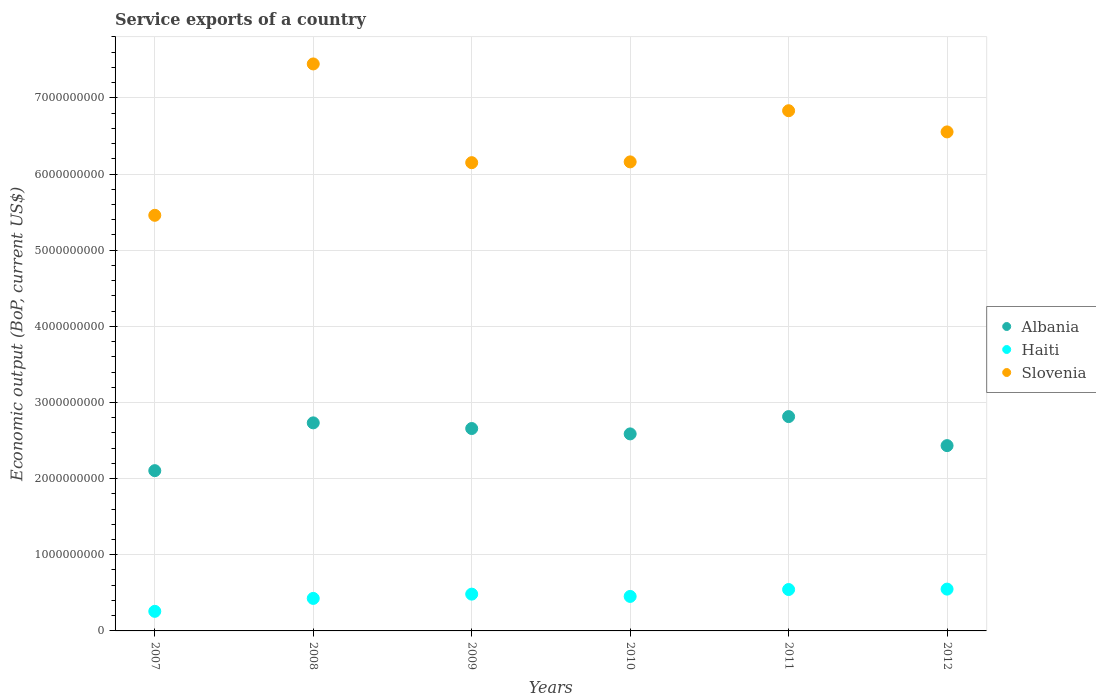What is the service exports in Albania in 2010?
Offer a very short reply. 2.59e+09. Across all years, what is the maximum service exports in Haiti?
Your answer should be very brief. 5.49e+08. Across all years, what is the minimum service exports in Haiti?
Give a very brief answer. 2.57e+08. In which year was the service exports in Slovenia maximum?
Provide a succinct answer. 2008. In which year was the service exports in Haiti minimum?
Your response must be concise. 2007. What is the total service exports in Albania in the graph?
Your response must be concise. 1.53e+1. What is the difference between the service exports in Slovenia in 2007 and that in 2010?
Offer a very short reply. -7.01e+08. What is the difference between the service exports in Haiti in 2012 and the service exports in Albania in 2009?
Give a very brief answer. -2.11e+09. What is the average service exports in Albania per year?
Your response must be concise. 2.55e+09. In the year 2010, what is the difference between the service exports in Haiti and service exports in Slovenia?
Provide a short and direct response. -5.71e+09. In how many years, is the service exports in Albania greater than 3000000000 US$?
Offer a very short reply. 0. What is the ratio of the service exports in Haiti in 2010 to that in 2012?
Offer a terse response. 0.83. Is the difference between the service exports in Haiti in 2007 and 2009 greater than the difference between the service exports in Slovenia in 2007 and 2009?
Make the answer very short. Yes. What is the difference between the highest and the second highest service exports in Haiti?
Your response must be concise. 5.39e+06. What is the difference between the highest and the lowest service exports in Albania?
Your answer should be very brief. 7.10e+08. Does the service exports in Albania monotonically increase over the years?
Offer a terse response. No. Is the service exports in Albania strictly less than the service exports in Slovenia over the years?
Offer a very short reply. Yes. How many dotlines are there?
Your response must be concise. 3. What is the difference between two consecutive major ticks on the Y-axis?
Provide a short and direct response. 1.00e+09. Does the graph contain any zero values?
Offer a terse response. No. Does the graph contain grids?
Give a very brief answer. Yes. Where does the legend appear in the graph?
Offer a terse response. Center right. How are the legend labels stacked?
Provide a short and direct response. Vertical. What is the title of the graph?
Provide a short and direct response. Service exports of a country. Does "Bulgaria" appear as one of the legend labels in the graph?
Ensure brevity in your answer.  No. What is the label or title of the Y-axis?
Offer a very short reply. Economic output (BoP, current US$). What is the Economic output (BoP, current US$) of Albania in 2007?
Offer a terse response. 2.10e+09. What is the Economic output (BoP, current US$) of Haiti in 2007?
Provide a short and direct response. 2.57e+08. What is the Economic output (BoP, current US$) in Slovenia in 2007?
Your answer should be very brief. 5.46e+09. What is the Economic output (BoP, current US$) of Albania in 2008?
Make the answer very short. 2.73e+09. What is the Economic output (BoP, current US$) of Haiti in 2008?
Give a very brief answer. 4.27e+08. What is the Economic output (BoP, current US$) in Slovenia in 2008?
Your answer should be compact. 7.45e+09. What is the Economic output (BoP, current US$) in Albania in 2009?
Your answer should be compact. 2.66e+09. What is the Economic output (BoP, current US$) in Haiti in 2009?
Provide a succinct answer. 4.83e+08. What is the Economic output (BoP, current US$) of Slovenia in 2009?
Your answer should be very brief. 6.15e+09. What is the Economic output (BoP, current US$) of Albania in 2010?
Make the answer very short. 2.59e+09. What is the Economic output (BoP, current US$) in Haiti in 2010?
Offer a very short reply. 4.53e+08. What is the Economic output (BoP, current US$) of Slovenia in 2010?
Provide a succinct answer. 6.16e+09. What is the Economic output (BoP, current US$) of Albania in 2011?
Keep it short and to the point. 2.81e+09. What is the Economic output (BoP, current US$) in Haiti in 2011?
Offer a very short reply. 5.44e+08. What is the Economic output (BoP, current US$) of Slovenia in 2011?
Provide a short and direct response. 6.83e+09. What is the Economic output (BoP, current US$) of Albania in 2012?
Ensure brevity in your answer.  2.43e+09. What is the Economic output (BoP, current US$) in Haiti in 2012?
Offer a terse response. 5.49e+08. What is the Economic output (BoP, current US$) of Slovenia in 2012?
Give a very brief answer. 6.55e+09. Across all years, what is the maximum Economic output (BoP, current US$) in Albania?
Your answer should be very brief. 2.81e+09. Across all years, what is the maximum Economic output (BoP, current US$) of Haiti?
Your response must be concise. 5.49e+08. Across all years, what is the maximum Economic output (BoP, current US$) of Slovenia?
Provide a succinct answer. 7.45e+09. Across all years, what is the minimum Economic output (BoP, current US$) of Albania?
Offer a very short reply. 2.10e+09. Across all years, what is the minimum Economic output (BoP, current US$) in Haiti?
Keep it short and to the point. 2.57e+08. Across all years, what is the minimum Economic output (BoP, current US$) of Slovenia?
Your answer should be very brief. 5.46e+09. What is the total Economic output (BoP, current US$) of Albania in the graph?
Give a very brief answer. 1.53e+1. What is the total Economic output (BoP, current US$) of Haiti in the graph?
Offer a terse response. 2.71e+09. What is the total Economic output (BoP, current US$) of Slovenia in the graph?
Your answer should be compact. 3.86e+1. What is the difference between the Economic output (BoP, current US$) of Albania in 2007 and that in 2008?
Keep it short and to the point. -6.28e+08. What is the difference between the Economic output (BoP, current US$) in Haiti in 2007 and that in 2008?
Your answer should be compact. -1.70e+08. What is the difference between the Economic output (BoP, current US$) in Slovenia in 2007 and that in 2008?
Your answer should be very brief. -1.99e+09. What is the difference between the Economic output (BoP, current US$) of Albania in 2007 and that in 2009?
Your answer should be very brief. -5.53e+08. What is the difference between the Economic output (BoP, current US$) of Haiti in 2007 and that in 2009?
Provide a short and direct response. -2.26e+08. What is the difference between the Economic output (BoP, current US$) of Slovenia in 2007 and that in 2009?
Ensure brevity in your answer.  -6.91e+08. What is the difference between the Economic output (BoP, current US$) in Albania in 2007 and that in 2010?
Ensure brevity in your answer.  -4.83e+08. What is the difference between the Economic output (BoP, current US$) of Haiti in 2007 and that in 2010?
Give a very brief answer. -1.96e+08. What is the difference between the Economic output (BoP, current US$) in Slovenia in 2007 and that in 2010?
Your answer should be very brief. -7.01e+08. What is the difference between the Economic output (BoP, current US$) in Albania in 2007 and that in 2011?
Your answer should be very brief. -7.10e+08. What is the difference between the Economic output (BoP, current US$) in Haiti in 2007 and that in 2011?
Offer a terse response. -2.86e+08. What is the difference between the Economic output (BoP, current US$) in Slovenia in 2007 and that in 2011?
Keep it short and to the point. -1.37e+09. What is the difference between the Economic output (BoP, current US$) in Albania in 2007 and that in 2012?
Ensure brevity in your answer.  -3.29e+08. What is the difference between the Economic output (BoP, current US$) of Haiti in 2007 and that in 2012?
Provide a short and direct response. -2.92e+08. What is the difference between the Economic output (BoP, current US$) in Slovenia in 2007 and that in 2012?
Offer a very short reply. -1.10e+09. What is the difference between the Economic output (BoP, current US$) of Albania in 2008 and that in 2009?
Keep it short and to the point. 7.43e+07. What is the difference between the Economic output (BoP, current US$) in Haiti in 2008 and that in 2009?
Provide a succinct answer. -5.60e+07. What is the difference between the Economic output (BoP, current US$) in Slovenia in 2008 and that in 2009?
Make the answer very short. 1.30e+09. What is the difference between the Economic output (BoP, current US$) of Albania in 2008 and that in 2010?
Make the answer very short. 1.45e+08. What is the difference between the Economic output (BoP, current US$) in Haiti in 2008 and that in 2010?
Ensure brevity in your answer.  -2.60e+07. What is the difference between the Economic output (BoP, current US$) of Slovenia in 2008 and that in 2010?
Your response must be concise. 1.29e+09. What is the difference between the Economic output (BoP, current US$) in Albania in 2008 and that in 2011?
Provide a short and direct response. -8.23e+07. What is the difference between the Economic output (BoP, current US$) of Haiti in 2008 and that in 2011?
Offer a very short reply. -1.17e+08. What is the difference between the Economic output (BoP, current US$) in Slovenia in 2008 and that in 2011?
Offer a very short reply. 6.14e+08. What is the difference between the Economic output (BoP, current US$) of Albania in 2008 and that in 2012?
Give a very brief answer. 2.99e+08. What is the difference between the Economic output (BoP, current US$) of Haiti in 2008 and that in 2012?
Your response must be concise. -1.22e+08. What is the difference between the Economic output (BoP, current US$) of Slovenia in 2008 and that in 2012?
Offer a very short reply. 8.92e+08. What is the difference between the Economic output (BoP, current US$) in Albania in 2009 and that in 2010?
Offer a terse response. 7.07e+07. What is the difference between the Economic output (BoP, current US$) of Haiti in 2009 and that in 2010?
Ensure brevity in your answer.  3.00e+07. What is the difference between the Economic output (BoP, current US$) of Slovenia in 2009 and that in 2010?
Provide a short and direct response. -1.02e+07. What is the difference between the Economic output (BoP, current US$) of Albania in 2009 and that in 2011?
Your answer should be very brief. -1.57e+08. What is the difference between the Economic output (BoP, current US$) of Haiti in 2009 and that in 2011?
Ensure brevity in your answer.  -6.06e+07. What is the difference between the Economic output (BoP, current US$) of Slovenia in 2009 and that in 2011?
Make the answer very short. -6.82e+08. What is the difference between the Economic output (BoP, current US$) in Albania in 2009 and that in 2012?
Give a very brief answer. 2.25e+08. What is the difference between the Economic output (BoP, current US$) in Haiti in 2009 and that in 2012?
Provide a succinct answer. -6.60e+07. What is the difference between the Economic output (BoP, current US$) of Slovenia in 2009 and that in 2012?
Offer a very short reply. -4.04e+08. What is the difference between the Economic output (BoP, current US$) of Albania in 2010 and that in 2011?
Your response must be concise. -2.27e+08. What is the difference between the Economic output (BoP, current US$) of Haiti in 2010 and that in 2011?
Provide a succinct answer. -9.06e+07. What is the difference between the Economic output (BoP, current US$) of Slovenia in 2010 and that in 2011?
Offer a terse response. -6.72e+08. What is the difference between the Economic output (BoP, current US$) of Albania in 2010 and that in 2012?
Offer a terse response. 1.54e+08. What is the difference between the Economic output (BoP, current US$) in Haiti in 2010 and that in 2012?
Give a very brief answer. -9.60e+07. What is the difference between the Economic output (BoP, current US$) in Slovenia in 2010 and that in 2012?
Offer a very short reply. -3.94e+08. What is the difference between the Economic output (BoP, current US$) in Albania in 2011 and that in 2012?
Your answer should be compact. 3.81e+08. What is the difference between the Economic output (BoP, current US$) of Haiti in 2011 and that in 2012?
Give a very brief answer. -5.39e+06. What is the difference between the Economic output (BoP, current US$) in Slovenia in 2011 and that in 2012?
Provide a succinct answer. 2.78e+08. What is the difference between the Economic output (BoP, current US$) in Albania in 2007 and the Economic output (BoP, current US$) in Haiti in 2008?
Your answer should be very brief. 1.68e+09. What is the difference between the Economic output (BoP, current US$) in Albania in 2007 and the Economic output (BoP, current US$) in Slovenia in 2008?
Give a very brief answer. -5.34e+09. What is the difference between the Economic output (BoP, current US$) in Haiti in 2007 and the Economic output (BoP, current US$) in Slovenia in 2008?
Provide a short and direct response. -7.19e+09. What is the difference between the Economic output (BoP, current US$) in Albania in 2007 and the Economic output (BoP, current US$) in Haiti in 2009?
Keep it short and to the point. 1.62e+09. What is the difference between the Economic output (BoP, current US$) of Albania in 2007 and the Economic output (BoP, current US$) of Slovenia in 2009?
Ensure brevity in your answer.  -4.04e+09. What is the difference between the Economic output (BoP, current US$) in Haiti in 2007 and the Economic output (BoP, current US$) in Slovenia in 2009?
Keep it short and to the point. -5.89e+09. What is the difference between the Economic output (BoP, current US$) in Albania in 2007 and the Economic output (BoP, current US$) in Haiti in 2010?
Provide a succinct answer. 1.65e+09. What is the difference between the Economic output (BoP, current US$) in Albania in 2007 and the Economic output (BoP, current US$) in Slovenia in 2010?
Keep it short and to the point. -4.05e+09. What is the difference between the Economic output (BoP, current US$) of Haiti in 2007 and the Economic output (BoP, current US$) of Slovenia in 2010?
Provide a short and direct response. -5.90e+09. What is the difference between the Economic output (BoP, current US$) of Albania in 2007 and the Economic output (BoP, current US$) of Haiti in 2011?
Provide a short and direct response. 1.56e+09. What is the difference between the Economic output (BoP, current US$) in Albania in 2007 and the Economic output (BoP, current US$) in Slovenia in 2011?
Your answer should be very brief. -4.73e+09. What is the difference between the Economic output (BoP, current US$) of Haiti in 2007 and the Economic output (BoP, current US$) of Slovenia in 2011?
Your answer should be very brief. -6.57e+09. What is the difference between the Economic output (BoP, current US$) in Albania in 2007 and the Economic output (BoP, current US$) in Haiti in 2012?
Your answer should be very brief. 1.56e+09. What is the difference between the Economic output (BoP, current US$) in Albania in 2007 and the Economic output (BoP, current US$) in Slovenia in 2012?
Your response must be concise. -4.45e+09. What is the difference between the Economic output (BoP, current US$) in Haiti in 2007 and the Economic output (BoP, current US$) in Slovenia in 2012?
Make the answer very short. -6.30e+09. What is the difference between the Economic output (BoP, current US$) in Albania in 2008 and the Economic output (BoP, current US$) in Haiti in 2009?
Provide a short and direct response. 2.25e+09. What is the difference between the Economic output (BoP, current US$) of Albania in 2008 and the Economic output (BoP, current US$) of Slovenia in 2009?
Keep it short and to the point. -3.42e+09. What is the difference between the Economic output (BoP, current US$) of Haiti in 2008 and the Economic output (BoP, current US$) of Slovenia in 2009?
Your answer should be compact. -5.72e+09. What is the difference between the Economic output (BoP, current US$) in Albania in 2008 and the Economic output (BoP, current US$) in Haiti in 2010?
Keep it short and to the point. 2.28e+09. What is the difference between the Economic output (BoP, current US$) of Albania in 2008 and the Economic output (BoP, current US$) of Slovenia in 2010?
Ensure brevity in your answer.  -3.43e+09. What is the difference between the Economic output (BoP, current US$) of Haiti in 2008 and the Economic output (BoP, current US$) of Slovenia in 2010?
Ensure brevity in your answer.  -5.73e+09. What is the difference between the Economic output (BoP, current US$) in Albania in 2008 and the Economic output (BoP, current US$) in Haiti in 2011?
Offer a terse response. 2.19e+09. What is the difference between the Economic output (BoP, current US$) in Albania in 2008 and the Economic output (BoP, current US$) in Slovenia in 2011?
Keep it short and to the point. -4.10e+09. What is the difference between the Economic output (BoP, current US$) of Haiti in 2008 and the Economic output (BoP, current US$) of Slovenia in 2011?
Give a very brief answer. -6.40e+09. What is the difference between the Economic output (BoP, current US$) in Albania in 2008 and the Economic output (BoP, current US$) in Haiti in 2012?
Ensure brevity in your answer.  2.18e+09. What is the difference between the Economic output (BoP, current US$) of Albania in 2008 and the Economic output (BoP, current US$) of Slovenia in 2012?
Offer a terse response. -3.82e+09. What is the difference between the Economic output (BoP, current US$) of Haiti in 2008 and the Economic output (BoP, current US$) of Slovenia in 2012?
Offer a terse response. -6.13e+09. What is the difference between the Economic output (BoP, current US$) of Albania in 2009 and the Economic output (BoP, current US$) of Haiti in 2010?
Provide a succinct answer. 2.20e+09. What is the difference between the Economic output (BoP, current US$) in Albania in 2009 and the Economic output (BoP, current US$) in Slovenia in 2010?
Offer a terse response. -3.50e+09. What is the difference between the Economic output (BoP, current US$) of Haiti in 2009 and the Economic output (BoP, current US$) of Slovenia in 2010?
Your answer should be very brief. -5.68e+09. What is the difference between the Economic output (BoP, current US$) in Albania in 2009 and the Economic output (BoP, current US$) in Haiti in 2011?
Give a very brief answer. 2.11e+09. What is the difference between the Economic output (BoP, current US$) in Albania in 2009 and the Economic output (BoP, current US$) in Slovenia in 2011?
Make the answer very short. -4.17e+09. What is the difference between the Economic output (BoP, current US$) in Haiti in 2009 and the Economic output (BoP, current US$) in Slovenia in 2011?
Provide a succinct answer. -6.35e+09. What is the difference between the Economic output (BoP, current US$) of Albania in 2009 and the Economic output (BoP, current US$) of Haiti in 2012?
Provide a short and direct response. 2.11e+09. What is the difference between the Economic output (BoP, current US$) in Albania in 2009 and the Economic output (BoP, current US$) in Slovenia in 2012?
Keep it short and to the point. -3.89e+09. What is the difference between the Economic output (BoP, current US$) of Haiti in 2009 and the Economic output (BoP, current US$) of Slovenia in 2012?
Make the answer very short. -6.07e+09. What is the difference between the Economic output (BoP, current US$) of Albania in 2010 and the Economic output (BoP, current US$) of Haiti in 2011?
Provide a short and direct response. 2.04e+09. What is the difference between the Economic output (BoP, current US$) in Albania in 2010 and the Economic output (BoP, current US$) in Slovenia in 2011?
Offer a very short reply. -4.24e+09. What is the difference between the Economic output (BoP, current US$) in Haiti in 2010 and the Economic output (BoP, current US$) in Slovenia in 2011?
Provide a short and direct response. -6.38e+09. What is the difference between the Economic output (BoP, current US$) of Albania in 2010 and the Economic output (BoP, current US$) of Haiti in 2012?
Your answer should be very brief. 2.04e+09. What is the difference between the Economic output (BoP, current US$) of Albania in 2010 and the Economic output (BoP, current US$) of Slovenia in 2012?
Offer a very short reply. -3.97e+09. What is the difference between the Economic output (BoP, current US$) of Haiti in 2010 and the Economic output (BoP, current US$) of Slovenia in 2012?
Offer a very short reply. -6.10e+09. What is the difference between the Economic output (BoP, current US$) of Albania in 2011 and the Economic output (BoP, current US$) of Haiti in 2012?
Offer a very short reply. 2.27e+09. What is the difference between the Economic output (BoP, current US$) in Albania in 2011 and the Economic output (BoP, current US$) in Slovenia in 2012?
Provide a succinct answer. -3.74e+09. What is the difference between the Economic output (BoP, current US$) in Haiti in 2011 and the Economic output (BoP, current US$) in Slovenia in 2012?
Keep it short and to the point. -6.01e+09. What is the average Economic output (BoP, current US$) of Albania per year?
Your response must be concise. 2.55e+09. What is the average Economic output (BoP, current US$) of Haiti per year?
Offer a terse response. 4.52e+08. What is the average Economic output (BoP, current US$) in Slovenia per year?
Provide a succinct answer. 6.43e+09. In the year 2007, what is the difference between the Economic output (BoP, current US$) in Albania and Economic output (BoP, current US$) in Haiti?
Provide a succinct answer. 1.85e+09. In the year 2007, what is the difference between the Economic output (BoP, current US$) in Albania and Economic output (BoP, current US$) in Slovenia?
Offer a terse response. -3.35e+09. In the year 2007, what is the difference between the Economic output (BoP, current US$) in Haiti and Economic output (BoP, current US$) in Slovenia?
Provide a succinct answer. -5.20e+09. In the year 2008, what is the difference between the Economic output (BoP, current US$) of Albania and Economic output (BoP, current US$) of Haiti?
Your response must be concise. 2.31e+09. In the year 2008, what is the difference between the Economic output (BoP, current US$) in Albania and Economic output (BoP, current US$) in Slovenia?
Your answer should be compact. -4.71e+09. In the year 2008, what is the difference between the Economic output (BoP, current US$) in Haiti and Economic output (BoP, current US$) in Slovenia?
Your response must be concise. -7.02e+09. In the year 2009, what is the difference between the Economic output (BoP, current US$) of Albania and Economic output (BoP, current US$) of Haiti?
Offer a very short reply. 2.17e+09. In the year 2009, what is the difference between the Economic output (BoP, current US$) in Albania and Economic output (BoP, current US$) in Slovenia?
Offer a very short reply. -3.49e+09. In the year 2009, what is the difference between the Economic output (BoP, current US$) of Haiti and Economic output (BoP, current US$) of Slovenia?
Provide a succinct answer. -5.67e+09. In the year 2010, what is the difference between the Economic output (BoP, current US$) in Albania and Economic output (BoP, current US$) in Haiti?
Your answer should be very brief. 2.13e+09. In the year 2010, what is the difference between the Economic output (BoP, current US$) of Albania and Economic output (BoP, current US$) of Slovenia?
Offer a terse response. -3.57e+09. In the year 2010, what is the difference between the Economic output (BoP, current US$) of Haiti and Economic output (BoP, current US$) of Slovenia?
Provide a succinct answer. -5.71e+09. In the year 2011, what is the difference between the Economic output (BoP, current US$) in Albania and Economic output (BoP, current US$) in Haiti?
Make the answer very short. 2.27e+09. In the year 2011, what is the difference between the Economic output (BoP, current US$) in Albania and Economic output (BoP, current US$) in Slovenia?
Ensure brevity in your answer.  -4.02e+09. In the year 2011, what is the difference between the Economic output (BoP, current US$) in Haiti and Economic output (BoP, current US$) in Slovenia?
Provide a succinct answer. -6.29e+09. In the year 2012, what is the difference between the Economic output (BoP, current US$) in Albania and Economic output (BoP, current US$) in Haiti?
Provide a succinct answer. 1.88e+09. In the year 2012, what is the difference between the Economic output (BoP, current US$) in Albania and Economic output (BoP, current US$) in Slovenia?
Your answer should be very brief. -4.12e+09. In the year 2012, what is the difference between the Economic output (BoP, current US$) in Haiti and Economic output (BoP, current US$) in Slovenia?
Keep it short and to the point. -6.00e+09. What is the ratio of the Economic output (BoP, current US$) of Albania in 2007 to that in 2008?
Make the answer very short. 0.77. What is the ratio of the Economic output (BoP, current US$) in Haiti in 2007 to that in 2008?
Your response must be concise. 0.6. What is the ratio of the Economic output (BoP, current US$) of Slovenia in 2007 to that in 2008?
Your answer should be very brief. 0.73. What is the ratio of the Economic output (BoP, current US$) in Albania in 2007 to that in 2009?
Give a very brief answer. 0.79. What is the ratio of the Economic output (BoP, current US$) of Haiti in 2007 to that in 2009?
Give a very brief answer. 0.53. What is the ratio of the Economic output (BoP, current US$) of Slovenia in 2007 to that in 2009?
Provide a short and direct response. 0.89. What is the ratio of the Economic output (BoP, current US$) of Albania in 2007 to that in 2010?
Ensure brevity in your answer.  0.81. What is the ratio of the Economic output (BoP, current US$) of Haiti in 2007 to that in 2010?
Provide a succinct answer. 0.57. What is the ratio of the Economic output (BoP, current US$) of Slovenia in 2007 to that in 2010?
Your answer should be compact. 0.89. What is the ratio of the Economic output (BoP, current US$) of Albania in 2007 to that in 2011?
Give a very brief answer. 0.75. What is the ratio of the Economic output (BoP, current US$) of Haiti in 2007 to that in 2011?
Your answer should be very brief. 0.47. What is the ratio of the Economic output (BoP, current US$) in Slovenia in 2007 to that in 2011?
Make the answer very short. 0.8. What is the ratio of the Economic output (BoP, current US$) in Albania in 2007 to that in 2012?
Offer a very short reply. 0.86. What is the ratio of the Economic output (BoP, current US$) in Haiti in 2007 to that in 2012?
Your answer should be compact. 0.47. What is the ratio of the Economic output (BoP, current US$) in Slovenia in 2007 to that in 2012?
Your answer should be very brief. 0.83. What is the ratio of the Economic output (BoP, current US$) in Albania in 2008 to that in 2009?
Give a very brief answer. 1.03. What is the ratio of the Economic output (BoP, current US$) of Haiti in 2008 to that in 2009?
Make the answer very short. 0.88. What is the ratio of the Economic output (BoP, current US$) of Slovenia in 2008 to that in 2009?
Give a very brief answer. 1.21. What is the ratio of the Economic output (BoP, current US$) of Albania in 2008 to that in 2010?
Provide a succinct answer. 1.06. What is the ratio of the Economic output (BoP, current US$) in Haiti in 2008 to that in 2010?
Your answer should be very brief. 0.94. What is the ratio of the Economic output (BoP, current US$) of Slovenia in 2008 to that in 2010?
Ensure brevity in your answer.  1.21. What is the ratio of the Economic output (BoP, current US$) of Albania in 2008 to that in 2011?
Offer a very short reply. 0.97. What is the ratio of the Economic output (BoP, current US$) in Haiti in 2008 to that in 2011?
Your answer should be very brief. 0.79. What is the ratio of the Economic output (BoP, current US$) of Slovenia in 2008 to that in 2011?
Your response must be concise. 1.09. What is the ratio of the Economic output (BoP, current US$) in Albania in 2008 to that in 2012?
Provide a succinct answer. 1.12. What is the ratio of the Economic output (BoP, current US$) in Slovenia in 2008 to that in 2012?
Give a very brief answer. 1.14. What is the ratio of the Economic output (BoP, current US$) in Albania in 2009 to that in 2010?
Ensure brevity in your answer.  1.03. What is the ratio of the Economic output (BoP, current US$) of Haiti in 2009 to that in 2010?
Provide a short and direct response. 1.07. What is the ratio of the Economic output (BoP, current US$) in Haiti in 2009 to that in 2011?
Ensure brevity in your answer.  0.89. What is the ratio of the Economic output (BoP, current US$) in Slovenia in 2009 to that in 2011?
Your answer should be compact. 0.9. What is the ratio of the Economic output (BoP, current US$) of Albania in 2009 to that in 2012?
Give a very brief answer. 1.09. What is the ratio of the Economic output (BoP, current US$) in Haiti in 2009 to that in 2012?
Offer a very short reply. 0.88. What is the ratio of the Economic output (BoP, current US$) of Slovenia in 2009 to that in 2012?
Make the answer very short. 0.94. What is the ratio of the Economic output (BoP, current US$) in Albania in 2010 to that in 2011?
Offer a very short reply. 0.92. What is the ratio of the Economic output (BoP, current US$) of Slovenia in 2010 to that in 2011?
Offer a terse response. 0.9. What is the ratio of the Economic output (BoP, current US$) in Albania in 2010 to that in 2012?
Provide a short and direct response. 1.06. What is the ratio of the Economic output (BoP, current US$) in Haiti in 2010 to that in 2012?
Ensure brevity in your answer.  0.83. What is the ratio of the Economic output (BoP, current US$) in Slovenia in 2010 to that in 2012?
Your answer should be compact. 0.94. What is the ratio of the Economic output (BoP, current US$) of Albania in 2011 to that in 2012?
Offer a terse response. 1.16. What is the ratio of the Economic output (BoP, current US$) in Haiti in 2011 to that in 2012?
Provide a short and direct response. 0.99. What is the ratio of the Economic output (BoP, current US$) in Slovenia in 2011 to that in 2012?
Provide a short and direct response. 1.04. What is the difference between the highest and the second highest Economic output (BoP, current US$) in Albania?
Your answer should be very brief. 8.23e+07. What is the difference between the highest and the second highest Economic output (BoP, current US$) of Haiti?
Provide a succinct answer. 5.39e+06. What is the difference between the highest and the second highest Economic output (BoP, current US$) in Slovenia?
Provide a succinct answer. 6.14e+08. What is the difference between the highest and the lowest Economic output (BoP, current US$) of Albania?
Provide a short and direct response. 7.10e+08. What is the difference between the highest and the lowest Economic output (BoP, current US$) of Haiti?
Offer a terse response. 2.92e+08. What is the difference between the highest and the lowest Economic output (BoP, current US$) of Slovenia?
Ensure brevity in your answer.  1.99e+09. 